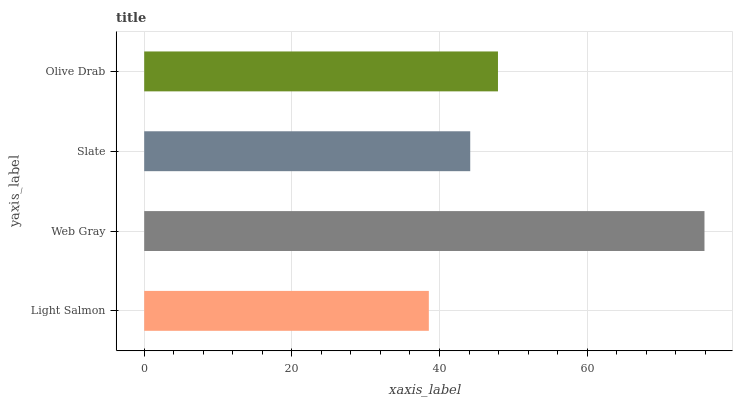Is Light Salmon the minimum?
Answer yes or no. Yes. Is Web Gray the maximum?
Answer yes or no. Yes. Is Slate the minimum?
Answer yes or no. No. Is Slate the maximum?
Answer yes or no. No. Is Web Gray greater than Slate?
Answer yes or no. Yes. Is Slate less than Web Gray?
Answer yes or no. Yes. Is Slate greater than Web Gray?
Answer yes or no. No. Is Web Gray less than Slate?
Answer yes or no. No. Is Olive Drab the high median?
Answer yes or no. Yes. Is Slate the low median?
Answer yes or no. Yes. Is Light Salmon the high median?
Answer yes or no. No. Is Web Gray the low median?
Answer yes or no. No. 